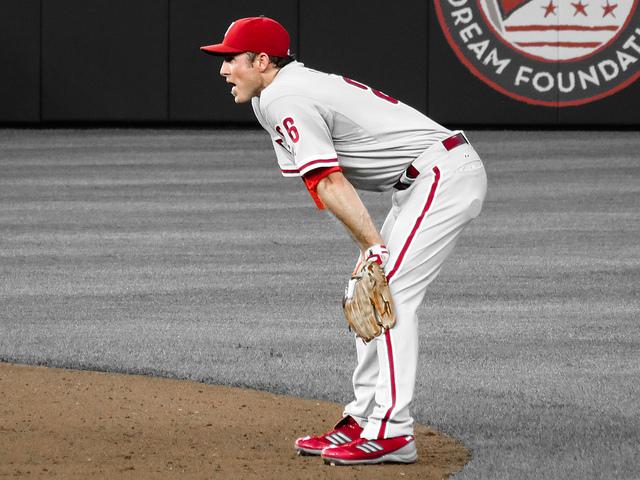Is he wearing a Red Hat?
Keep it brief. Yes. What color are his shoes?
Concise answer only. Red. Is the man tired?
Short answer required. Yes. What does the person have on their right hand?
Quick response, please. Nothing. 